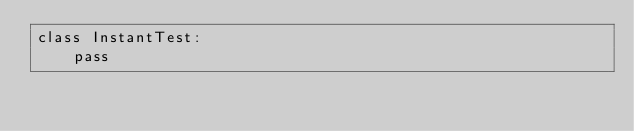<code> <loc_0><loc_0><loc_500><loc_500><_Python_>class InstantTest:
    pass
</code> 